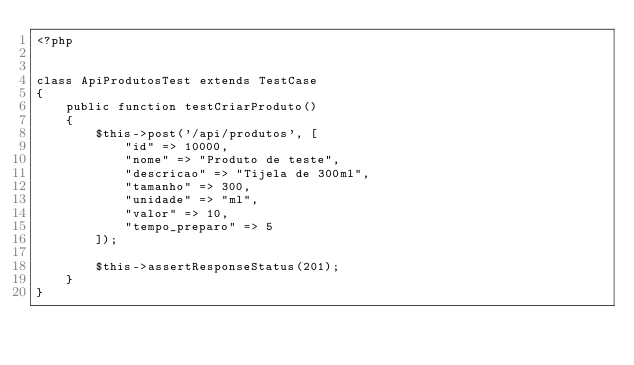<code> <loc_0><loc_0><loc_500><loc_500><_PHP_><?php


class ApiProdutosTest extends TestCase
{
    public function testCriarProduto()
    {
        $this->post('/api/produtos', [
            "id" => 10000,
            "nome" => "Produto de teste",
            "descricao" => "Tijela de 300ml",
            "tamanho" => 300,
            "unidade" => "ml",
            "valor" => 10,
            "tempo_preparo" => 5
        ]);

        $this->assertResponseStatus(201);
    }
}
</code> 